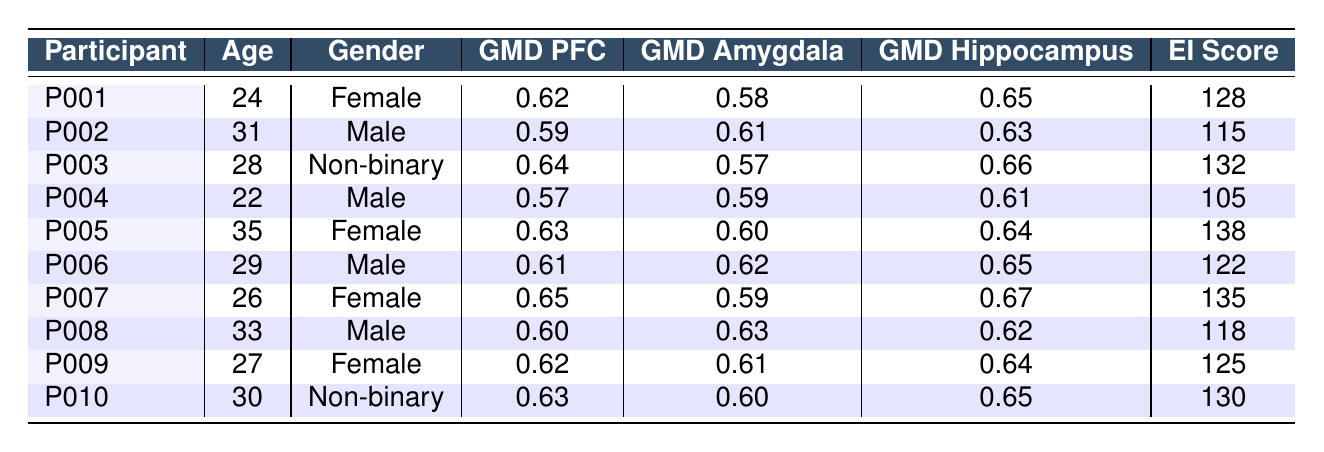What is the emotional intelligence score of participant P005? Looking at the table, participant P005 has an emotional intelligence score listed under the EI Score column. The score is clearly indicated as 138.
Answer: 138 What is the gray matter density in the hippocampus for participant P009? The table shows the gray matter density values for each region. For participant P009, the gray matter density in the hippocampus is listed as 0.64.
Answer: 0.64 Which participant has the highest gray matter density in the prefrontal cortex? By comparing the GMD PFC values, participant P007 has the highest gray matter density at 0.65.
Answer: P007 What is the average emotional intelligence score for all participants? To calculate the average, we will sum all the EI scores: 128 + 115 + 132 + 105 + 138 + 122 + 135 + 118 + 125 + 130 = 1317. There are 10 participants, so we divide 1317 by 10, which gives us 131.7.
Answer: 131.7 Is participant P001's gray matter density in the amygdala higher than that of participant P004? For participant P001, the gray matter density in the amygdala is 0.58, while for participant P004 it is 0.59. Therefore, 0.58 is not higher than 0.59, which makes this statement false.
Answer: No What is the difference in emotional intelligence scores between participant P005 and participant P004? To find the difference, we take P005’s score of 138 and subtract P004’s score of 105: 138 - 105 = 33.
Answer: 33 Which gender has the lowest average emotional intelligence score among the participants? First, we calculate the average scores for each gender. Females: (128 + 138 + 135 + 125) / 4 = 131.5; Males: (115 + 105 + 122 + 118) / 4 = 115; Non-binary: (132 + 130) / 2 = 131. Therefore, males have the lowest average EI score.
Answer: Male Does a higher gray matter density in the prefrontal cortex correlate with a higher emotional intelligence score based on the table? We will look for a trend: participant comparisons show that P007 (GMD PFC = 0.65) has an EI score of 135, while P006 (GMD PFC = 0.61) has an EI score of 122. This suggests a trend, but a full correlation analysis is required for definitive conclusions.
Answer: Yes, suggests a correlation What is the maximum gray matter density in the amygdala among the participants? Upon checking the GMD Amygdala values, P002 has the highest value at 0.61.
Answer: 0.61 What is the emotional intelligence score of the oldest participant? The oldest participant is P005 at age 35 with an emotional intelligence score of 138.
Answer: 138 